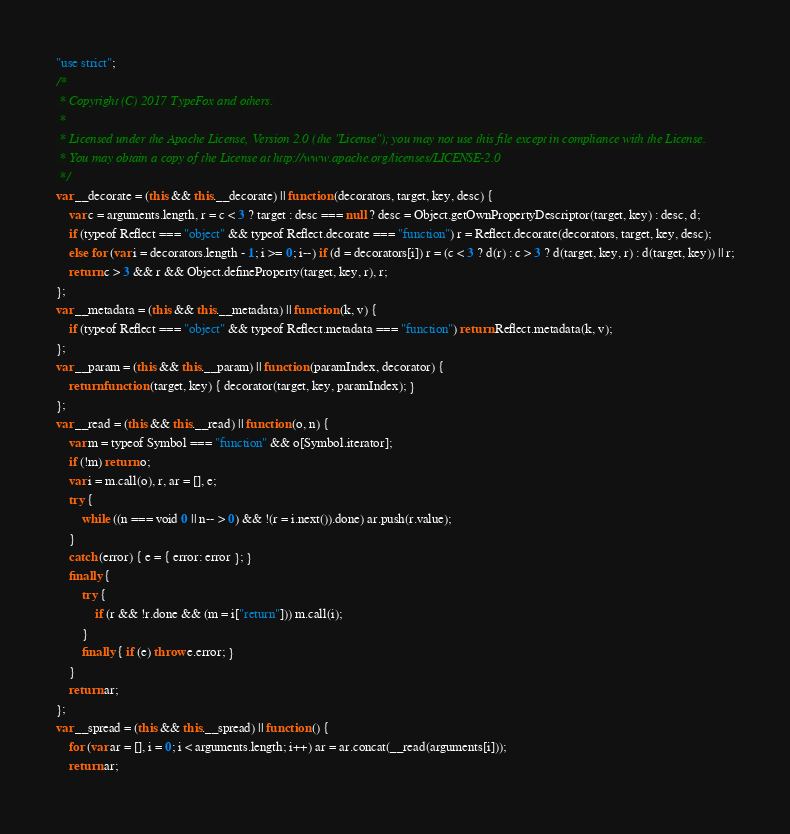Convert code to text. <code><loc_0><loc_0><loc_500><loc_500><_JavaScript_>"use strict";
/*
 * Copyright (C) 2017 TypeFox and others.
 *
 * Licensed under the Apache License, Version 2.0 (the "License"); you may not use this file except in compliance with the License.
 * You may obtain a copy of the License at http://www.apache.org/licenses/LICENSE-2.0
 */
var __decorate = (this && this.__decorate) || function (decorators, target, key, desc) {
    var c = arguments.length, r = c < 3 ? target : desc === null ? desc = Object.getOwnPropertyDescriptor(target, key) : desc, d;
    if (typeof Reflect === "object" && typeof Reflect.decorate === "function") r = Reflect.decorate(decorators, target, key, desc);
    else for (var i = decorators.length - 1; i >= 0; i--) if (d = decorators[i]) r = (c < 3 ? d(r) : c > 3 ? d(target, key, r) : d(target, key)) || r;
    return c > 3 && r && Object.defineProperty(target, key, r), r;
};
var __metadata = (this && this.__metadata) || function (k, v) {
    if (typeof Reflect === "object" && typeof Reflect.metadata === "function") return Reflect.metadata(k, v);
};
var __param = (this && this.__param) || function (paramIndex, decorator) {
    return function (target, key) { decorator(target, key, paramIndex); }
};
var __read = (this && this.__read) || function (o, n) {
    var m = typeof Symbol === "function" && o[Symbol.iterator];
    if (!m) return o;
    var i = m.call(o), r, ar = [], e;
    try {
        while ((n === void 0 || n-- > 0) && !(r = i.next()).done) ar.push(r.value);
    }
    catch (error) { e = { error: error }; }
    finally {
        try {
            if (r && !r.done && (m = i["return"])) m.call(i);
        }
        finally { if (e) throw e.error; }
    }
    return ar;
};
var __spread = (this && this.__spread) || function () {
    for (var ar = [], i = 0; i < arguments.length; i++) ar = ar.concat(__read(arguments[i]));
    return ar;</code> 